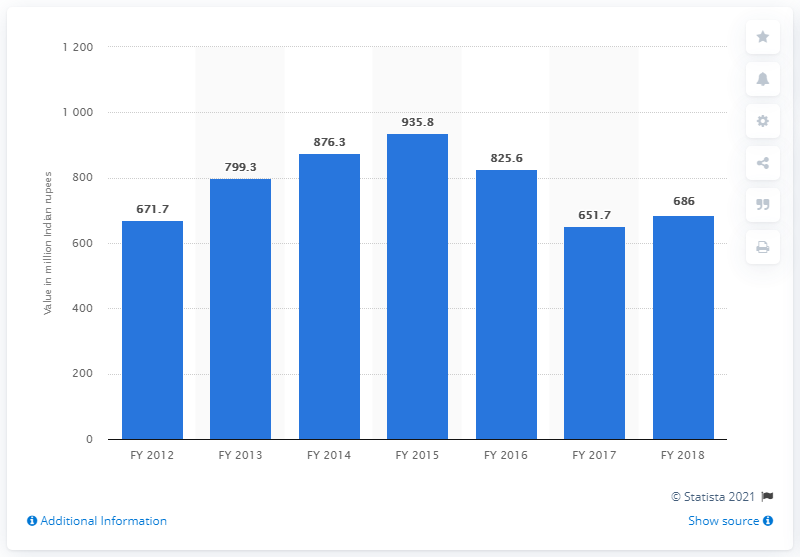Point out several critical features in this image. In the Indian economy in fiscal year 2018, condiments and spices from Bihar accounted for 686 million Indian rupees in terms of their contribution to the overall economy. 